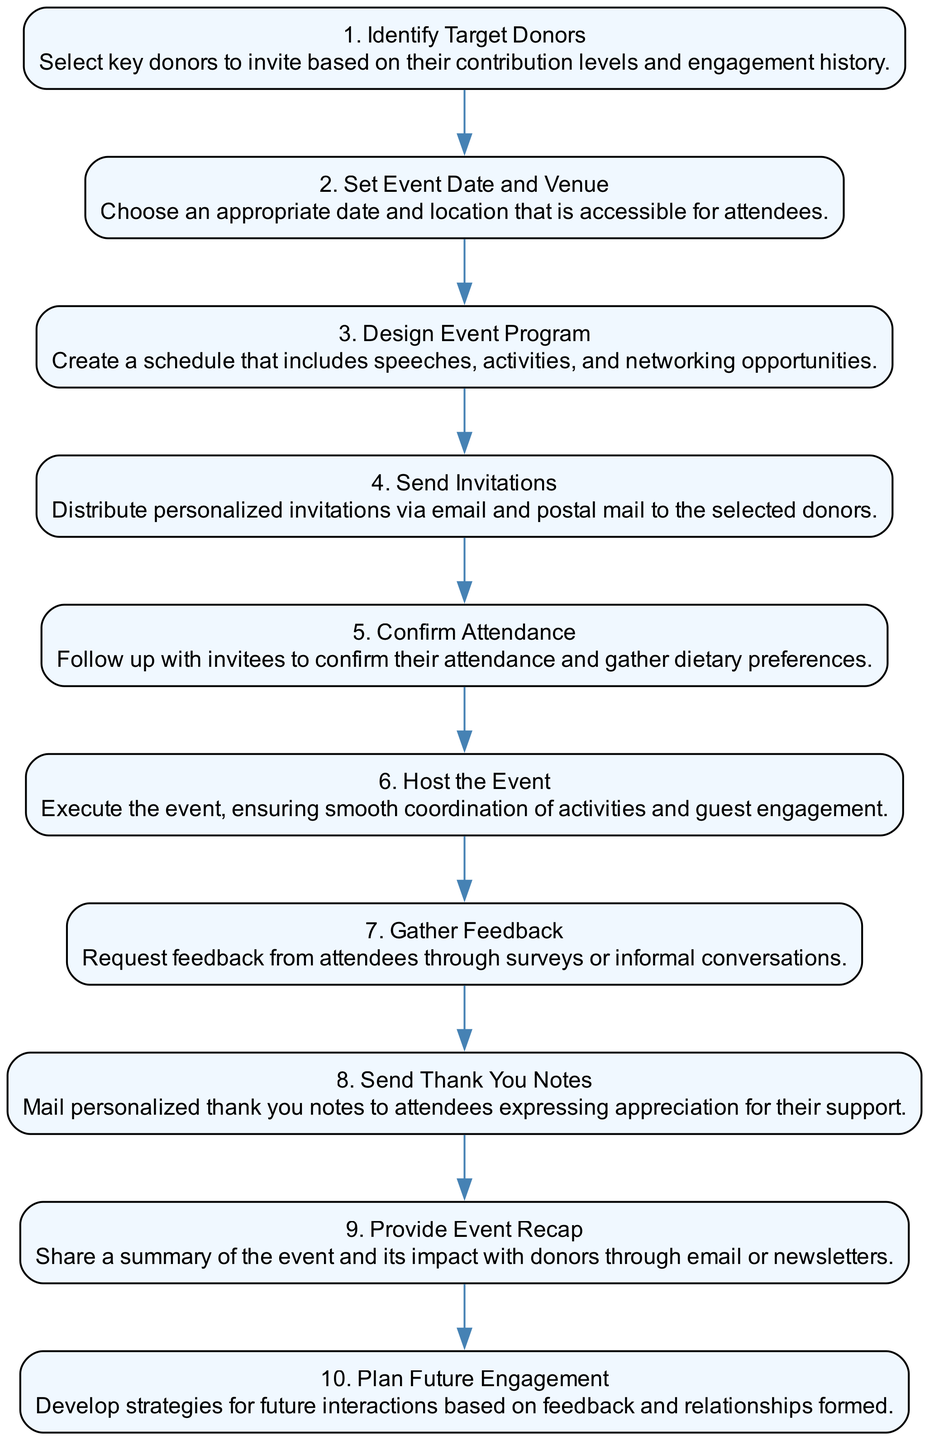What is the first step in organizing the donor appreciation event? The first step in the sequence diagram is labeled as "1. Identify Target Donors," which is the first node in the flow.
Answer: Identify Target Donors How many steps are involved in the event organization process? By counting the nodes in the sequence diagram, we determine that there are ten distinct steps represented.
Answer: 10 What is the last activity performed after the event? The last step in the sequence diagram is labeled as "10. Plan Future Engagement," suggesting it occurs after all prior activities are completed.
Answer: Plan Future Engagement Which step requires gathering dietary preferences? In the sequence diagram, "5. Confirm Attendance" specifically mentions gathering dietary preferences as part of the follow-up after sending invites.
Answer: Confirm Attendance What action is taken immediately after hosting the event? After "6. Host the Event," the next action in the sequence diagram is "7. Gather Feedback," indicating that feedback collection immediately follows the event.
Answer: Gather Feedback What is the main purpose of sending thank you notes? In the sequence diagram, "8. Send Thank You Notes" refers to expressing appreciation for support, highlighting the importance of acknowledging donor contributions.
Answer: Express appreciation for their support If a donor attends the event, what immediate follow-up action is expected? According to the sequence, after an attendee engages during the event, the next action is to "7. Gather Feedback," indicating that feedback is the immediate follow-up.
Answer: Gather Feedback How are donors invited to the event? The sequence diagram specifies "4. Send Invitations," which mentions distributing personalized invitations via email and postal mail as the method of inviting donors.
Answer: Distribute personalized invitations Which step involves summarizing the event's impact? The step "9. Provide Event Recap" focuses on sharing a summary of the event's impact with donors, highlighting how feedback is communicated after the event.
Answer: Provide Event Recap What type of activity is contained in step 3? The step labeled "3. Design Event Program" indicates that this activity involves creating a schedule that includes speeches, activities, and networking opportunities.
Answer: Create a schedule 